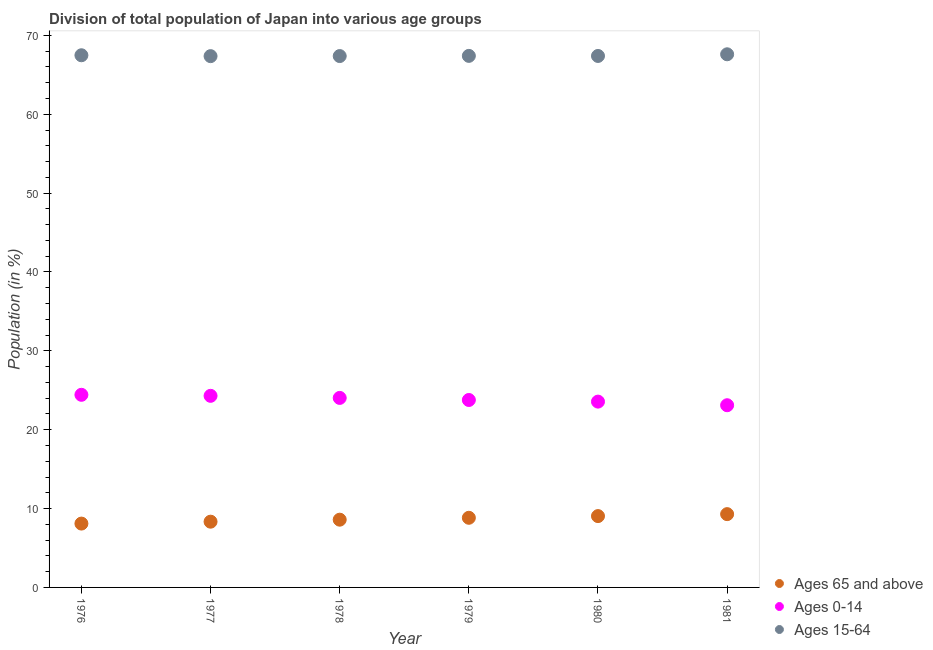Is the number of dotlines equal to the number of legend labels?
Keep it short and to the point. Yes. What is the percentage of population within the age-group 0-14 in 1980?
Ensure brevity in your answer.  23.56. Across all years, what is the maximum percentage of population within the age-group of 65 and above?
Give a very brief answer. 9.29. Across all years, what is the minimum percentage of population within the age-group 0-14?
Your response must be concise. 23.1. In which year was the percentage of population within the age-group 15-64 maximum?
Your answer should be compact. 1981. In which year was the percentage of population within the age-group of 65 and above minimum?
Your answer should be very brief. 1976. What is the total percentage of population within the age-group 0-14 in the graph?
Keep it short and to the point. 143.18. What is the difference between the percentage of population within the age-group 15-64 in 1978 and that in 1981?
Make the answer very short. -0.22. What is the difference between the percentage of population within the age-group of 65 and above in 1979 and the percentage of population within the age-group 0-14 in 1976?
Offer a very short reply. -15.59. What is the average percentage of population within the age-group of 65 and above per year?
Your answer should be very brief. 8.7. In the year 1981, what is the difference between the percentage of population within the age-group of 65 and above and percentage of population within the age-group 15-64?
Make the answer very short. -58.31. In how many years, is the percentage of population within the age-group 0-14 greater than 12 %?
Provide a succinct answer. 6. What is the ratio of the percentage of population within the age-group 0-14 in 1977 to that in 1979?
Ensure brevity in your answer.  1.02. What is the difference between the highest and the second highest percentage of population within the age-group of 65 and above?
Your answer should be very brief. 0.25. What is the difference between the highest and the lowest percentage of population within the age-group 15-64?
Make the answer very short. 0.23. In how many years, is the percentage of population within the age-group of 65 and above greater than the average percentage of population within the age-group of 65 and above taken over all years?
Provide a short and direct response. 3. Is it the case that in every year, the sum of the percentage of population within the age-group of 65 and above and percentage of population within the age-group 0-14 is greater than the percentage of population within the age-group 15-64?
Your answer should be very brief. No. Does the percentage of population within the age-group 15-64 monotonically increase over the years?
Your answer should be compact. No. Is the percentage of population within the age-group 0-14 strictly greater than the percentage of population within the age-group of 65 and above over the years?
Ensure brevity in your answer.  Yes. Is the percentage of population within the age-group 15-64 strictly less than the percentage of population within the age-group 0-14 over the years?
Your answer should be compact. No. How many legend labels are there?
Your response must be concise. 3. What is the title of the graph?
Offer a very short reply. Division of total population of Japan into various age groups
. What is the label or title of the X-axis?
Provide a short and direct response. Year. What is the Population (in %) of Ages 65 and above in 1976?
Your answer should be very brief. 8.1. What is the Population (in %) in Ages 0-14 in 1976?
Provide a short and direct response. 24.42. What is the Population (in %) of Ages 15-64 in 1976?
Give a very brief answer. 67.48. What is the Population (in %) in Ages 65 and above in 1977?
Give a very brief answer. 8.34. What is the Population (in %) in Ages 0-14 in 1977?
Offer a terse response. 24.29. What is the Population (in %) in Ages 15-64 in 1977?
Make the answer very short. 67.37. What is the Population (in %) of Ages 65 and above in 1978?
Offer a terse response. 8.59. What is the Population (in %) of Ages 0-14 in 1978?
Offer a terse response. 24.03. What is the Population (in %) in Ages 15-64 in 1978?
Your answer should be very brief. 67.38. What is the Population (in %) of Ages 65 and above in 1979?
Offer a very short reply. 8.83. What is the Population (in %) in Ages 0-14 in 1979?
Offer a very short reply. 23.77. What is the Population (in %) of Ages 15-64 in 1979?
Your answer should be very brief. 67.4. What is the Population (in %) in Ages 65 and above in 1980?
Your response must be concise. 9.05. What is the Population (in %) in Ages 0-14 in 1980?
Give a very brief answer. 23.56. What is the Population (in %) in Ages 15-64 in 1980?
Keep it short and to the point. 67.39. What is the Population (in %) of Ages 65 and above in 1981?
Provide a short and direct response. 9.29. What is the Population (in %) in Ages 0-14 in 1981?
Offer a terse response. 23.1. What is the Population (in %) of Ages 15-64 in 1981?
Your response must be concise. 67.6. Across all years, what is the maximum Population (in %) in Ages 65 and above?
Keep it short and to the point. 9.29. Across all years, what is the maximum Population (in %) of Ages 0-14?
Make the answer very short. 24.42. Across all years, what is the maximum Population (in %) in Ages 15-64?
Your response must be concise. 67.6. Across all years, what is the minimum Population (in %) of Ages 65 and above?
Make the answer very short. 8.1. Across all years, what is the minimum Population (in %) of Ages 0-14?
Offer a terse response. 23.1. Across all years, what is the minimum Population (in %) in Ages 15-64?
Provide a succinct answer. 67.37. What is the total Population (in %) of Ages 65 and above in the graph?
Your response must be concise. 52.19. What is the total Population (in %) of Ages 0-14 in the graph?
Make the answer very short. 143.18. What is the total Population (in %) in Ages 15-64 in the graph?
Give a very brief answer. 404.62. What is the difference between the Population (in %) in Ages 65 and above in 1976 and that in 1977?
Your answer should be compact. -0.24. What is the difference between the Population (in %) in Ages 0-14 in 1976 and that in 1977?
Your answer should be compact. 0.13. What is the difference between the Population (in %) in Ages 15-64 in 1976 and that in 1977?
Give a very brief answer. 0.11. What is the difference between the Population (in %) in Ages 65 and above in 1976 and that in 1978?
Ensure brevity in your answer.  -0.49. What is the difference between the Population (in %) of Ages 0-14 in 1976 and that in 1978?
Give a very brief answer. 0.39. What is the difference between the Population (in %) in Ages 15-64 in 1976 and that in 1978?
Give a very brief answer. 0.1. What is the difference between the Population (in %) in Ages 65 and above in 1976 and that in 1979?
Your response must be concise. -0.74. What is the difference between the Population (in %) of Ages 0-14 in 1976 and that in 1979?
Keep it short and to the point. 0.66. What is the difference between the Population (in %) in Ages 15-64 in 1976 and that in 1979?
Make the answer very short. 0.08. What is the difference between the Population (in %) of Ages 65 and above in 1976 and that in 1980?
Make the answer very short. -0.95. What is the difference between the Population (in %) of Ages 0-14 in 1976 and that in 1980?
Offer a terse response. 0.86. What is the difference between the Population (in %) in Ages 15-64 in 1976 and that in 1980?
Provide a succinct answer. 0.09. What is the difference between the Population (in %) in Ages 65 and above in 1976 and that in 1981?
Offer a terse response. -1.2. What is the difference between the Population (in %) in Ages 0-14 in 1976 and that in 1981?
Ensure brevity in your answer.  1.32. What is the difference between the Population (in %) in Ages 15-64 in 1976 and that in 1981?
Your answer should be compact. -0.12. What is the difference between the Population (in %) in Ages 65 and above in 1977 and that in 1978?
Your answer should be very brief. -0.25. What is the difference between the Population (in %) in Ages 0-14 in 1977 and that in 1978?
Your answer should be compact. 0.26. What is the difference between the Population (in %) in Ages 15-64 in 1977 and that in 1978?
Keep it short and to the point. -0.01. What is the difference between the Population (in %) in Ages 65 and above in 1977 and that in 1979?
Your response must be concise. -0.49. What is the difference between the Population (in %) in Ages 0-14 in 1977 and that in 1979?
Keep it short and to the point. 0.53. What is the difference between the Population (in %) of Ages 15-64 in 1977 and that in 1979?
Give a very brief answer. -0.03. What is the difference between the Population (in %) of Ages 65 and above in 1977 and that in 1980?
Your answer should be compact. -0.71. What is the difference between the Population (in %) of Ages 0-14 in 1977 and that in 1980?
Your answer should be compact. 0.73. What is the difference between the Population (in %) in Ages 15-64 in 1977 and that in 1980?
Provide a short and direct response. -0.02. What is the difference between the Population (in %) of Ages 65 and above in 1977 and that in 1981?
Keep it short and to the point. -0.96. What is the difference between the Population (in %) of Ages 0-14 in 1977 and that in 1981?
Ensure brevity in your answer.  1.19. What is the difference between the Population (in %) of Ages 15-64 in 1977 and that in 1981?
Offer a very short reply. -0.23. What is the difference between the Population (in %) in Ages 65 and above in 1978 and that in 1979?
Your response must be concise. -0.24. What is the difference between the Population (in %) of Ages 0-14 in 1978 and that in 1979?
Provide a short and direct response. 0.26. What is the difference between the Population (in %) of Ages 15-64 in 1978 and that in 1979?
Provide a succinct answer. -0.02. What is the difference between the Population (in %) of Ages 65 and above in 1978 and that in 1980?
Offer a very short reply. -0.46. What is the difference between the Population (in %) in Ages 0-14 in 1978 and that in 1980?
Provide a short and direct response. 0.47. What is the difference between the Population (in %) of Ages 15-64 in 1978 and that in 1980?
Your response must be concise. -0.01. What is the difference between the Population (in %) in Ages 65 and above in 1978 and that in 1981?
Your answer should be very brief. -0.7. What is the difference between the Population (in %) in Ages 0-14 in 1978 and that in 1981?
Provide a succinct answer. 0.93. What is the difference between the Population (in %) of Ages 15-64 in 1978 and that in 1981?
Your response must be concise. -0.23. What is the difference between the Population (in %) in Ages 65 and above in 1979 and that in 1980?
Keep it short and to the point. -0.22. What is the difference between the Population (in %) in Ages 0-14 in 1979 and that in 1980?
Provide a short and direct response. 0.21. What is the difference between the Population (in %) in Ages 15-64 in 1979 and that in 1980?
Provide a short and direct response. 0.01. What is the difference between the Population (in %) of Ages 65 and above in 1979 and that in 1981?
Your answer should be compact. -0.46. What is the difference between the Population (in %) of Ages 0-14 in 1979 and that in 1981?
Provide a succinct answer. 0.66. What is the difference between the Population (in %) in Ages 15-64 in 1979 and that in 1981?
Your response must be concise. -0.2. What is the difference between the Population (in %) of Ages 65 and above in 1980 and that in 1981?
Your response must be concise. -0.25. What is the difference between the Population (in %) of Ages 0-14 in 1980 and that in 1981?
Offer a very short reply. 0.46. What is the difference between the Population (in %) in Ages 15-64 in 1980 and that in 1981?
Your response must be concise. -0.21. What is the difference between the Population (in %) of Ages 65 and above in 1976 and the Population (in %) of Ages 0-14 in 1977?
Your answer should be very brief. -16.2. What is the difference between the Population (in %) in Ages 65 and above in 1976 and the Population (in %) in Ages 15-64 in 1977?
Your answer should be very brief. -59.27. What is the difference between the Population (in %) of Ages 0-14 in 1976 and the Population (in %) of Ages 15-64 in 1977?
Provide a short and direct response. -42.94. What is the difference between the Population (in %) of Ages 65 and above in 1976 and the Population (in %) of Ages 0-14 in 1978?
Your response must be concise. -15.94. What is the difference between the Population (in %) of Ages 65 and above in 1976 and the Population (in %) of Ages 15-64 in 1978?
Make the answer very short. -59.28. What is the difference between the Population (in %) in Ages 0-14 in 1976 and the Population (in %) in Ages 15-64 in 1978?
Your response must be concise. -42.95. What is the difference between the Population (in %) in Ages 65 and above in 1976 and the Population (in %) in Ages 0-14 in 1979?
Keep it short and to the point. -15.67. What is the difference between the Population (in %) of Ages 65 and above in 1976 and the Population (in %) of Ages 15-64 in 1979?
Your answer should be compact. -59.31. What is the difference between the Population (in %) in Ages 0-14 in 1976 and the Population (in %) in Ages 15-64 in 1979?
Provide a short and direct response. -42.98. What is the difference between the Population (in %) in Ages 65 and above in 1976 and the Population (in %) in Ages 0-14 in 1980?
Ensure brevity in your answer.  -15.47. What is the difference between the Population (in %) of Ages 65 and above in 1976 and the Population (in %) of Ages 15-64 in 1980?
Provide a succinct answer. -59.3. What is the difference between the Population (in %) in Ages 0-14 in 1976 and the Population (in %) in Ages 15-64 in 1980?
Give a very brief answer. -42.97. What is the difference between the Population (in %) of Ages 65 and above in 1976 and the Population (in %) of Ages 0-14 in 1981?
Your answer should be very brief. -15.01. What is the difference between the Population (in %) in Ages 65 and above in 1976 and the Population (in %) in Ages 15-64 in 1981?
Your response must be concise. -59.51. What is the difference between the Population (in %) of Ages 0-14 in 1976 and the Population (in %) of Ages 15-64 in 1981?
Keep it short and to the point. -43.18. What is the difference between the Population (in %) of Ages 65 and above in 1977 and the Population (in %) of Ages 0-14 in 1978?
Make the answer very short. -15.69. What is the difference between the Population (in %) in Ages 65 and above in 1977 and the Population (in %) in Ages 15-64 in 1978?
Provide a short and direct response. -59.04. What is the difference between the Population (in %) in Ages 0-14 in 1977 and the Population (in %) in Ages 15-64 in 1978?
Keep it short and to the point. -43.08. What is the difference between the Population (in %) of Ages 65 and above in 1977 and the Population (in %) of Ages 0-14 in 1979?
Your answer should be compact. -15.43. What is the difference between the Population (in %) of Ages 65 and above in 1977 and the Population (in %) of Ages 15-64 in 1979?
Give a very brief answer. -59.06. What is the difference between the Population (in %) in Ages 0-14 in 1977 and the Population (in %) in Ages 15-64 in 1979?
Give a very brief answer. -43.11. What is the difference between the Population (in %) in Ages 65 and above in 1977 and the Population (in %) in Ages 0-14 in 1980?
Your answer should be compact. -15.23. What is the difference between the Population (in %) of Ages 65 and above in 1977 and the Population (in %) of Ages 15-64 in 1980?
Keep it short and to the point. -59.06. What is the difference between the Population (in %) in Ages 0-14 in 1977 and the Population (in %) in Ages 15-64 in 1980?
Provide a short and direct response. -43.1. What is the difference between the Population (in %) of Ages 65 and above in 1977 and the Population (in %) of Ages 0-14 in 1981?
Provide a succinct answer. -14.77. What is the difference between the Population (in %) of Ages 65 and above in 1977 and the Population (in %) of Ages 15-64 in 1981?
Provide a short and direct response. -59.27. What is the difference between the Population (in %) of Ages 0-14 in 1977 and the Population (in %) of Ages 15-64 in 1981?
Ensure brevity in your answer.  -43.31. What is the difference between the Population (in %) of Ages 65 and above in 1978 and the Population (in %) of Ages 0-14 in 1979?
Offer a very short reply. -15.18. What is the difference between the Population (in %) in Ages 65 and above in 1978 and the Population (in %) in Ages 15-64 in 1979?
Make the answer very short. -58.81. What is the difference between the Population (in %) of Ages 0-14 in 1978 and the Population (in %) of Ages 15-64 in 1979?
Your answer should be compact. -43.37. What is the difference between the Population (in %) of Ages 65 and above in 1978 and the Population (in %) of Ages 0-14 in 1980?
Offer a very short reply. -14.97. What is the difference between the Population (in %) of Ages 65 and above in 1978 and the Population (in %) of Ages 15-64 in 1980?
Make the answer very short. -58.8. What is the difference between the Population (in %) of Ages 0-14 in 1978 and the Population (in %) of Ages 15-64 in 1980?
Offer a very short reply. -43.36. What is the difference between the Population (in %) in Ages 65 and above in 1978 and the Population (in %) in Ages 0-14 in 1981?
Your answer should be compact. -14.51. What is the difference between the Population (in %) in Ages 65 and above in 1978 and the Population (in %) in Ages 15-64 in 1981?
Offer a very short reply. -59.01. What is the difference between the Population (in %) in Ages 0-14 in 1978 and the Population (in %) in Ages 15-64 in 1981?
Offer a very short reply. -43.57. What is the difference between the Population (in %) in Ages 65 and above in 1979 and the Population (in %) in Ages 0-14 in 1980?
Provide a short and direct response. -14.73. What is the difference between the Population (in %) in Ages 65 and above in 1979 and the Population (in %) in Ages 15-64 in 1980?
Provide a succinct answer. -58.56. What is the difference between the Population (in %) of Ages 0-14 in 1979 and the Population (in %) of Ages 15-64 in 1980?
Give a very brief answer. -43.62. What is the difference between the Population (in %) of Ages 65 and above in 1979 and the Population (in %) of Ages 0-14 in 1981?
Your answer should be very brief. -14.27. What is the difference between the Population (in %) in Ages 65 and above in 1979 and the Population (in %) in Ages 15-64 in 1981?
Offer a very short reply. -58.77. What is the difference between the Population (in %) in Ages 0-14 in 1979 and the Population (in %) in Ages 15-64 in 1981?
Provide a succinct answer. -43.84. What is the difference between the Population (in %) of Ages 65 and above in 1980 and the Population (in %) of Ages 0-14 in 1981?
Provide a short and direct response. -14.06. What is the difference between the Population (in %) in Ages 65 and above in 1980 and the Population (in %) in Ages 15-64 in 1981?
Your answer should be very brief. -58.56. What is the difference between the Population (in %) of Ages 0-14 in 1980 and the Population (in %) of Ages 15-64 in 1981?
Your answer should be very brief. -44.04. What is the average Population (in %) in Ages 65 and above per year?
Your response must be concise. 8.7. What is the average Population (in %) of Ages 0-14 per year?
Offer a terse response. 23.86. What is the average Population (in %) of Ages 15-64 per year?
Provide a succinct answer. 67.44. In the year 1976, what is the difference between the Population (in %) in Ages 65 and above and Population (in %) in Ages 0-14?
Offer a very short reply. -16.33. In the year 1976, what is the difference between the Population (in %) of Ages 65 and above and Population (in %) of Ages 15-64?
Make the answer very short. -59.38. In the year 1976, what is the difference between the Population (in %) in Ages 0-14 and Population (in %) in Ages 15-64?
Give a very brief answer. -43.06. In the year 1977, what is the difference between the Population (in %) of Ages 65 and above and Population (in %) of Ages 0-14?
Make the answer very short. -15.96. In the year 1977, what is the difference between the Population (in %) in Ages 65 and above and Population (in %) in Ages 15-64?
Offer a terse response. -59.03. In the year 1977, what is the difference between the Population (in %) in Ages 0-14 and Population (in %) in Ages 15-64?
Your response must be concise. -43.07. In the year 1978, what is the difference between the Population (in %) in Ages 65 and above and Population (in %) in Ages 0-14?
Provide a short and direct response. -15.44. In the year 1978, what is the difference between the Population (in %) of Ages 65 and above and Population (in %) of Ages 15-64?
Offer a very short reply. -58.79. In the year 1978, what is the difference between the Population (in %) of Ages 0-14 and Population (in %) of Ages 15-64?
Offer a terse response. -43.35. In the year 1979, what is the difference between the Population (in %) of Ages 65 and above and Population (in %) of Ages 0-14?
Offer a terse response. -14.94. In the year 1979, what is the difference between the Population (in %) in Ages 65 and above and Population (in %) in Ages 15-64?
Ensure brevity in your answer.  -58.57. In the year 1979, what is the difference between the Population (in %) in Ages 0-14 and Population (in %) in Ages 15-64?
Your response must be concise. -43.63. In the year 1980, what is the difference between the Population (in %) of Ages 65 and above and Population (in %) of Ages 0-14?
Offer a very short reply. -14.52. In the year 1980, what is the difference between the Population (in %) in Ages 65 and above and Population (in %) in Ages 15-64?
Give a very brief answer. -58.35. In the year 1980, what is the difference between the Population (in %) of Ages 0-14 and Population (in %) of Ages 15-64?
Your response must be concise. -43.83. In the year 1981, what is the difference between the Population (in %) of Ages 65 and above and Population (in %) of Ages 0-14?
Give a very brief answer. -13.81. In the year 1981, what is the difference between the Population (in %) in Ages 65 and above and Population (in %) in Ages 15-64?
Keep it short and to the point. -58.31. In the year 1981, what is the difference between the Population (in %) of Ages 0-14 and Population (in %) of Ages 15-64?
Offer a terse response. -44.5. What is the ratio of the Population (in %) in Ages 65 and above in 1976 to that in 1977?
Your answer should be compact. 0.97. What is the ratio of the Population (in %) in Ages 0-14 in 1976 to that in 1977?
Make the answer very short. 1.01. What is the ratio of the Population (in %) of Ages 65 and above in 1976 to that in 1978?
Offer a terse response. 0.94. What is the ratio of the Population (in %) of Ages 0-14 in 1976 to that in 1978?
Offer a very short reply. 1.02. What is the ratio of the Population (in %) in Ages 65 and above in 1976 to that in 1979?
Ensure brevity in your answer.  0.92. What is the ratio of the Population (in %) of Ages 0-14 in 1976 to that in 1979?
Offer a terse response. 1.03. What is the ratio of the Population (in %) of Ages 65 and above in 1976 to that in 1980?
Offer a terse response. 0.89. What is the ratio of the Population (in %) in Ages 0-14 in 1976 to that in 1980?
Offer a terse response. 1.04. What is the ratio of the Population (in %) in Ages 65 and above in 1976 to that in 1981?
Offer a terse response. 0.87. What is the ratio of the Population (in %) of Ages 0-14 in 1976 to that in 1981?
Your response must be concise. 1.06. What is the ratio of the Population (in %) of Ages 15-64 in 1976 to that in 1981?
Provide a succinct answer. 1. What is the ratio of the Population (in %) in Ages 65 and above in 1977 to that in 1978?
Give a very brief answer. 0.97. What is the ratio of the Population (in %) of Ages 0-14 in 1977 to that in 1978?
Make the answer very short. 1.01. What is the ratio of the Population (in %) in Ages 65 and above in 1977 to that in 1979?
Keep it short and to the point. 0.94. What is the ratio of the Population (in %) of Ages 0-14 in 1977 to that in 1979?
Keep it short and to the point. 1.02. What is the ratio of the Population (in %) of Ages 15-64 in 1977 to that in 1979?
Offer a terse response. 1. What is the ratio of the Population (in %) in Ages 65 and above in 1977 to that in 1980?
Provide a short and direct response. 0.92. What is the ratio of the Population (in %) of Ages 0-14 in 1977 to that in 1980?
Your response must be concise. 1.03. What is the ratio of the Population (in %) in Ages 65 and above in 1977 to that in 1981?
Offer a terse response. 0.9. What is the ratio of the Population (in %) in Ages 0-14 in 1977 to that in 1981?
Your response must be concise. 1.05. What is the ratio of the Population (in %) in Ages 15-64 in 1977 to that in 1981?
Make the answer very short. 1. What is the ratio of the Population (in %) of Ages 65 and above in 1978 to that in 1979?
Offer a very short reply. 0.97. What is the ratio of the Population (in %) in Ages 0-14 in 1978 to that in 1979?
Offer a very short reply. 1.01. What is the ratio of the Population (in %) in Ages 65 and above in 1978 to that in 1980?
Ensure brevity in your answer.  0.95. What is the ratio of the Population (in %) of Ages 0-14 in 1978 to that in 1980?
Your response must be concise. 1.02. What is the ratio of the Population (in %) of Ages 65 and above in 1978 to that in 1981?
Make the answer very short. 0.92. What is the ratio of the Population (in %) in Ages 0-14 in 1978 to that in 1981?
Your response must be concise. 1.04. What is the ratio of the Population (in %) in Ages 15-64 in 1978 to that in 1981?
Ensure brevity in your answer.  1. What is the ratio of the Population (in %) of Ages 65 and above in 1979 to that in 1980?
Offer a very short reply. 0.98. What is the ratio of the Population (in %) of Ages 0-14 in 1979 to that in 1980?
Your response must be concise. 1.01. What is the ratio of the Population (in %) of Ages 15-64 in 1979 to that in 1980?
Offer a terse response. 1. What is the ratio of the Population (in %) of Ages 65 and above in 1979 to that in 1981?
Your answer should be compact. 0.95. What is the ratio of the Population (in %) of Ages 0-14 in 1979 to that in 1981?
Provide a succinct answer. 1.03. What is the ratio of the Population (in %) in Ages 65 and above in 1980 to that in 1981?
Offer a very short reply. 0.97. What is the ratio of the Population (in %) in Ages 0-14 in 1980 to that in 1981?
Your answer should be very brief. 1.02. What is the difference between the highest and the second highest Population (in %) of Ages 65 and above?
Keep it short and to the point. 0.25. What is the difference between the highest and the second highest Population (in %) in Ages 0-14?
Offer a terse response. 0.13. What is the difference between the highest and the second highest Population (in %) of Ages 15-64?
Your answer should be compact. 0.12. What is the difference between the highest and the lowest Population (in %) in Ages 65 and above?
Your response must be concise. 1.2. What is the difference between the highest and the lowest Population (in %) of Ages 0-14?
Your answer should be compact. 1.32. What is the difference between the highest and the lowest Population (in %) in Ages 15-64?
Your answer should be very brief. 0.23. 